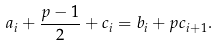Convert formula to latex. <formula><loc_0><loc_0><loc_500><loc_500>a _ { i } + \frac { p - 1 } { 2 } + c _ { i } = b _ { i } + p c _ { i + 1 } .</formula> 